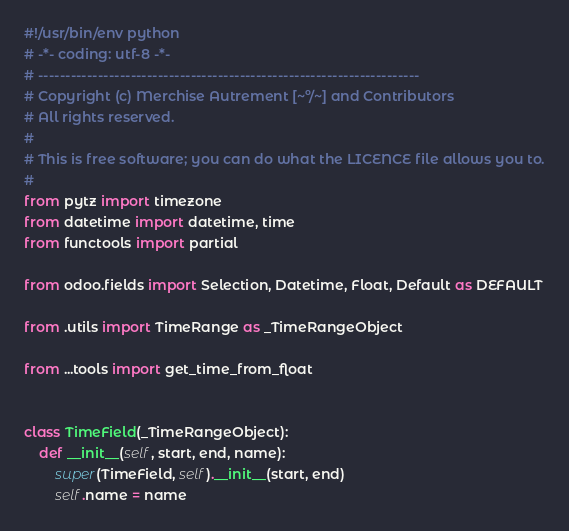<code> <loc_0><loc_0><loc_500><loc_500><_Python_>#!/usr/bin/env python
# -*- coding: utf-8 -*-
# ----------------------------------------------------------------------
# Copyright (c) Merchise Autrement [~º/~] and Contributors
# All rights reserved.
#
# This is free software; you can do what the LICENCE file allows you to.
#
from pytz import timezone
from datetime import datetime, time
from functools import partial

from odoo.fields import Selection, Datetime, Float, Default as DEFAULT

from .utils import TimeRange as _TimeRangeObject

from ...tools import get_time_from_float


class TimeField(_TimeRangeObject):
    def __init__(self, start, end, name):
        super(TimeField, self).__init__(start, end)
        self.name = name

</code> 